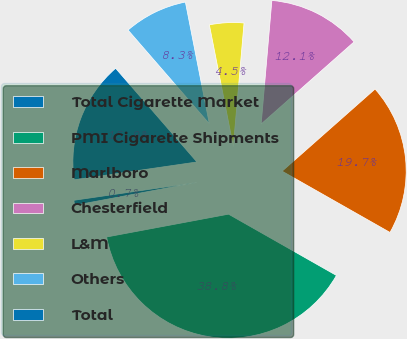Convert chart to OTSL. <chart><loc_0><loc_0><loc_500><loc_500><pie_chart><fcel>Total Cigarette Market<fcel>PMI Cigarette Shipments<fcel>Marlboro<fcel>Chesterfield<fcel>L&M<fcel>Others<fcel>Total<nl><fcel>0.65%<fcel>38.83%<fcel>19.74%<fcel>12.1%<fcel>4.47%<fcel>8.28%<fcel>15.92%<nl></chart> 